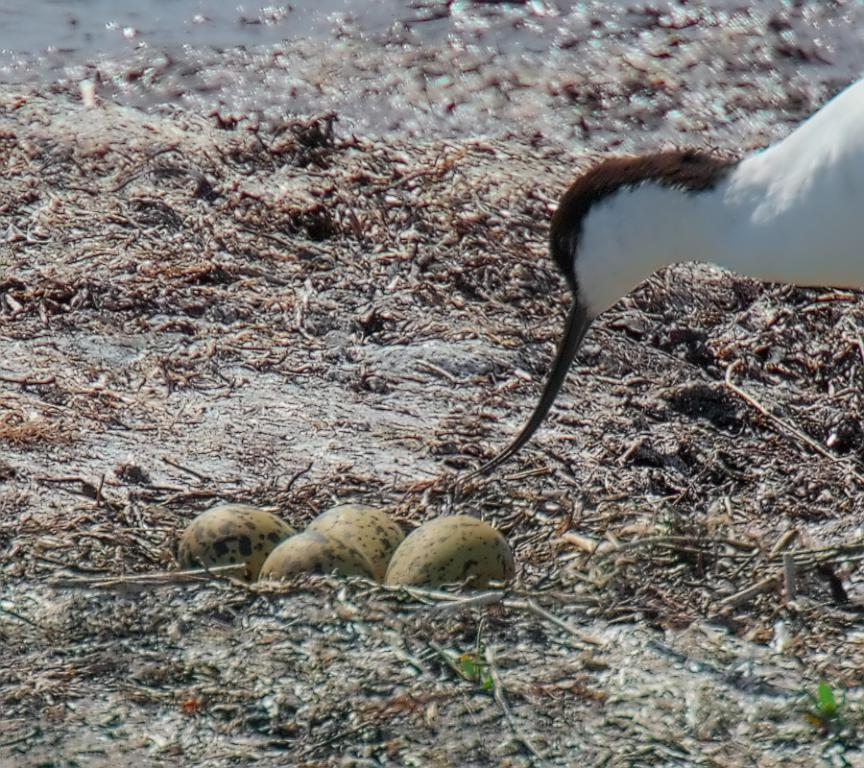What can be found in the nest in the image? There are eggs in a nest in the image. What animal is present on the ground in the image? A: There is a duck on the ground in the image. What type of plant material is visible in the image? There are dried stems visible in the image. What natural element is present in the image? There is water visible in the image. Where is the playground located in the image? There is no playground present in the image. How many snakes are slithering through the water in the image? There are no snakes visible in the image; it features a nest with eggs, a duck, dried stems, and water. 